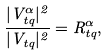<formula> <loc_0><loc_0><loc_500><loc_500>\frac { | V _ { t q } ^ { \alpha } | ^ { 2 } } { | V _ { t q } | ^ { 2 } } = R _ { t q } ^ { \alpha } ,</formula> 